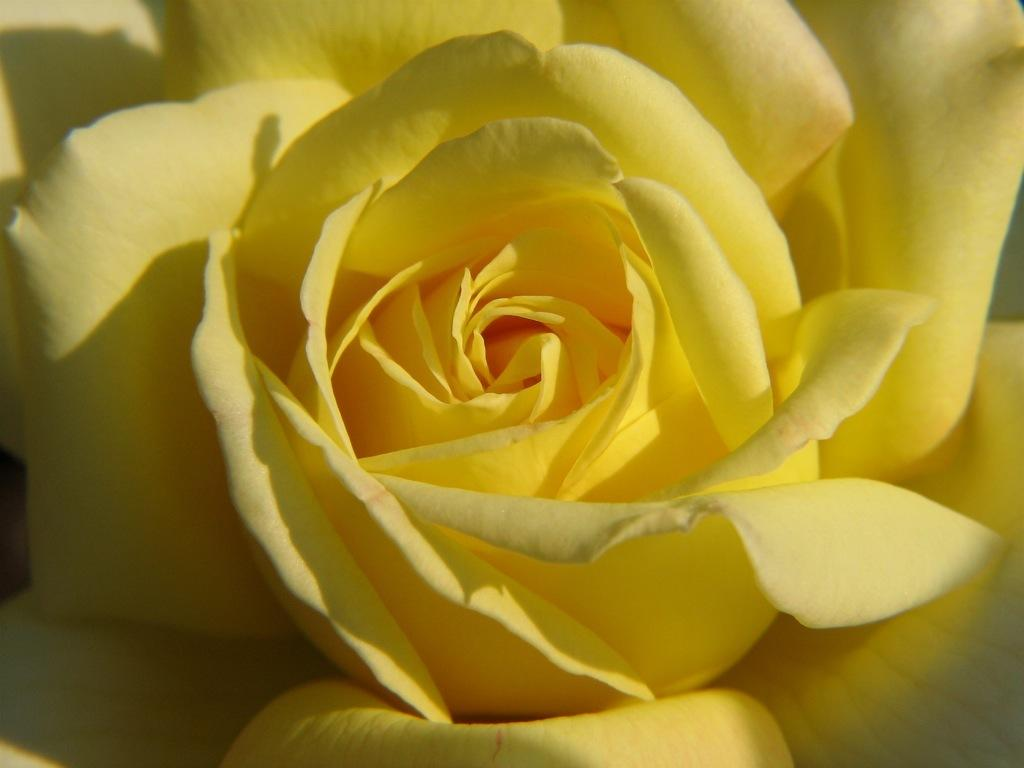What type of flower is present in the image? There is a yellow-colored rose in the image. Can you tell me how many animals are in the zoo in the image? There is no zoo present in the image, as it features a yellow-colored rose. What is the coefficient of friction between the rose and the surface it is placed on in the image? The coefficient of friction cannot be determined from the image, as it does not provide information about the surface or the physical properties of the rose. 